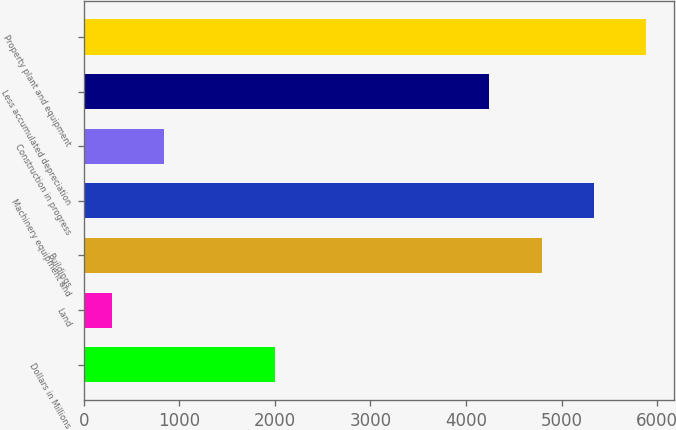Convert chart. <chart><loc_0><loc_0><loc_500><loc_500><bar_chart><fcel>Dollars in Millions<fcel>Land<fcel>Buildings<fcel>Machinery equipment and<fcel>Construction in progress<fcel>Less accumulated depreciation<fcel>Property plant and equipment<nl><fcel>2004<fcel>290<fcel>4791.5<fcel>5339<fcel>837.5<fcel>4244<fcel>5886.5<nl></chart> 